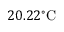<formula> <loc_0><loc_0><loc_500><loc_500>2 0 . 2 2 ^ { \circ } C</formula> 